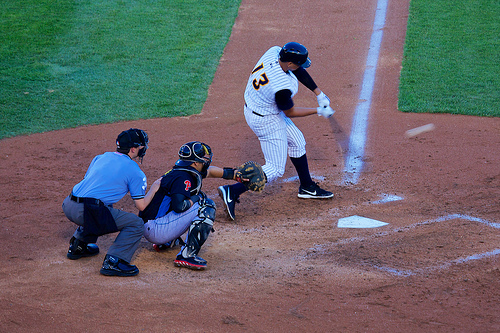Who do you think is wearing a shield? The umpire, needing protection from potential high-speed impacts, is wearing a shield. 